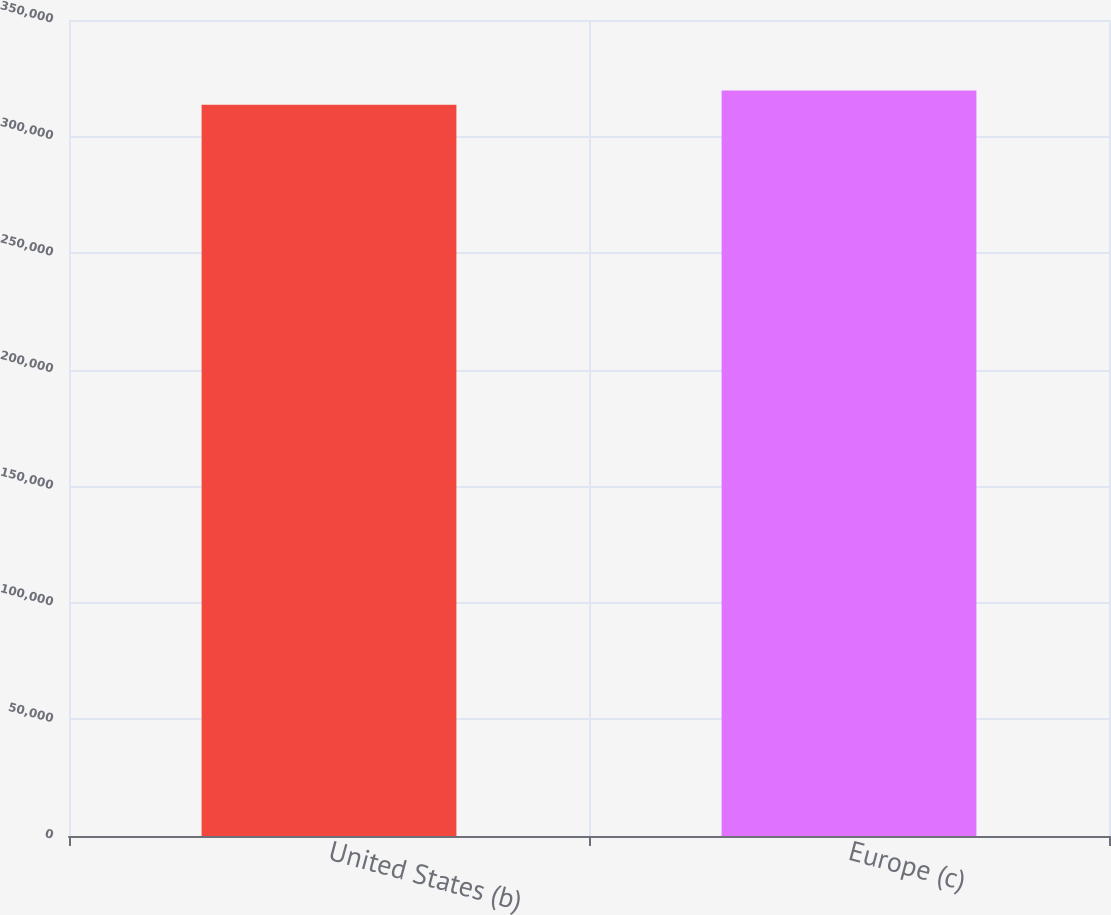Convert chart to OTSL. <chart><loc_0><loc_0><loc_500><loc_500><bar_chart><fcel>United States (b)<fcel>Europe (c)<nl><fcel>313627<fcel>319801<nl></chart> 